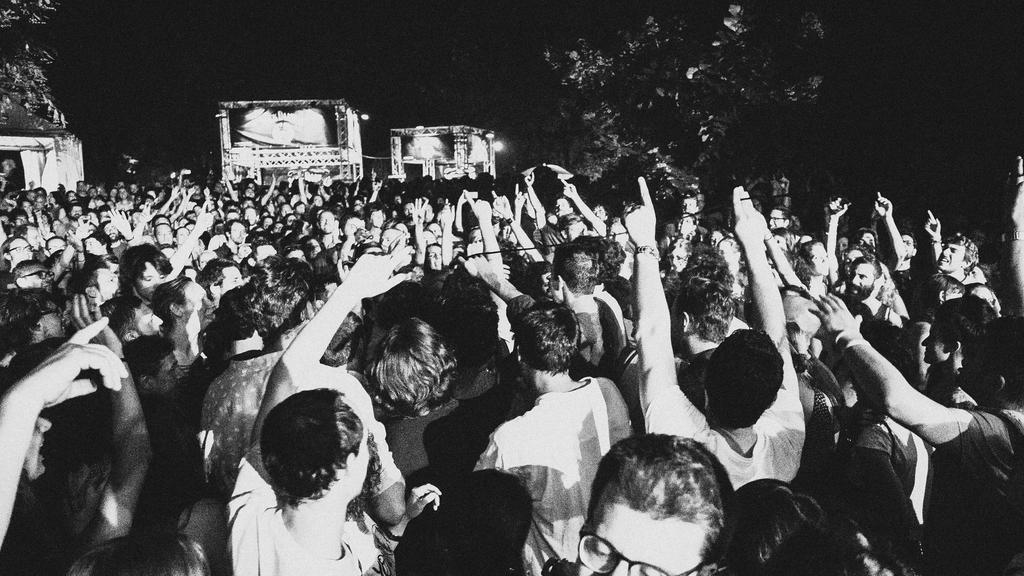What is the color scheme of the image? The image is black and white. What can be seen in the foreground of the image? There is a group of people standing in the image. What is visible in the background of the image? There are trees and objects in the background of the image. Can you describe the lighting in the image? There are lights visible in the image. What type of bird is perched on the canvas in the image? There is no canvas or bird present in the image. 